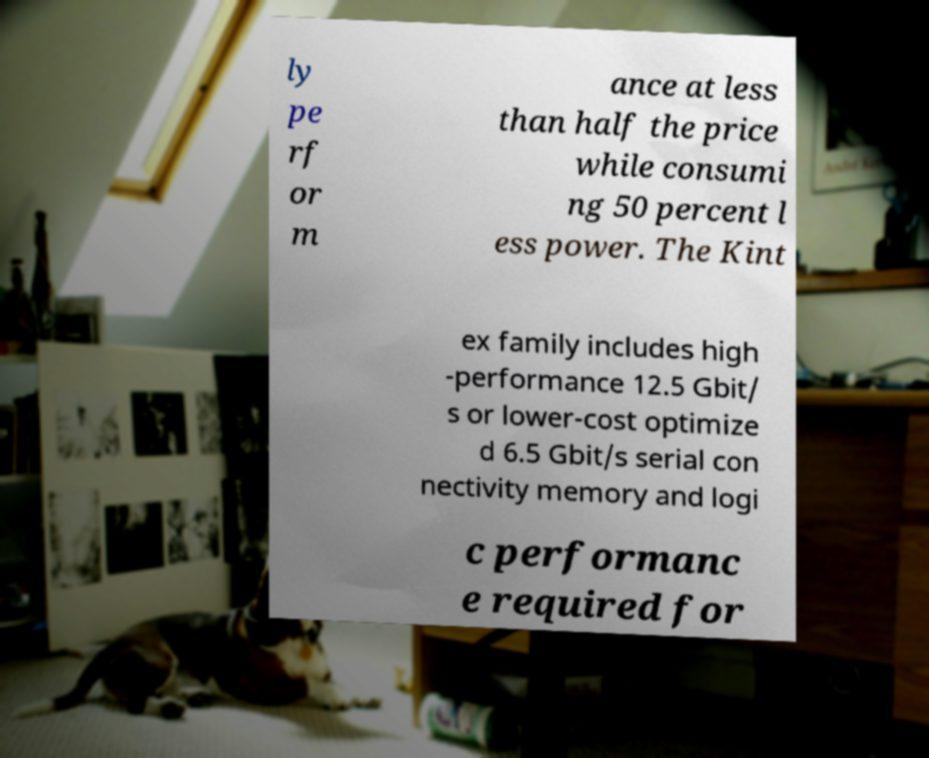Could you extract and type out the text from this image? ly pe rf or m ance at less than half the price while consumi ng 50 percent l ess power. The Kint ex family includes high -performance 12.5 Gbit/ s or lower-cost optimize d 6.5 Gbit/s serial con nectivity memory and logi c performanc e required for 